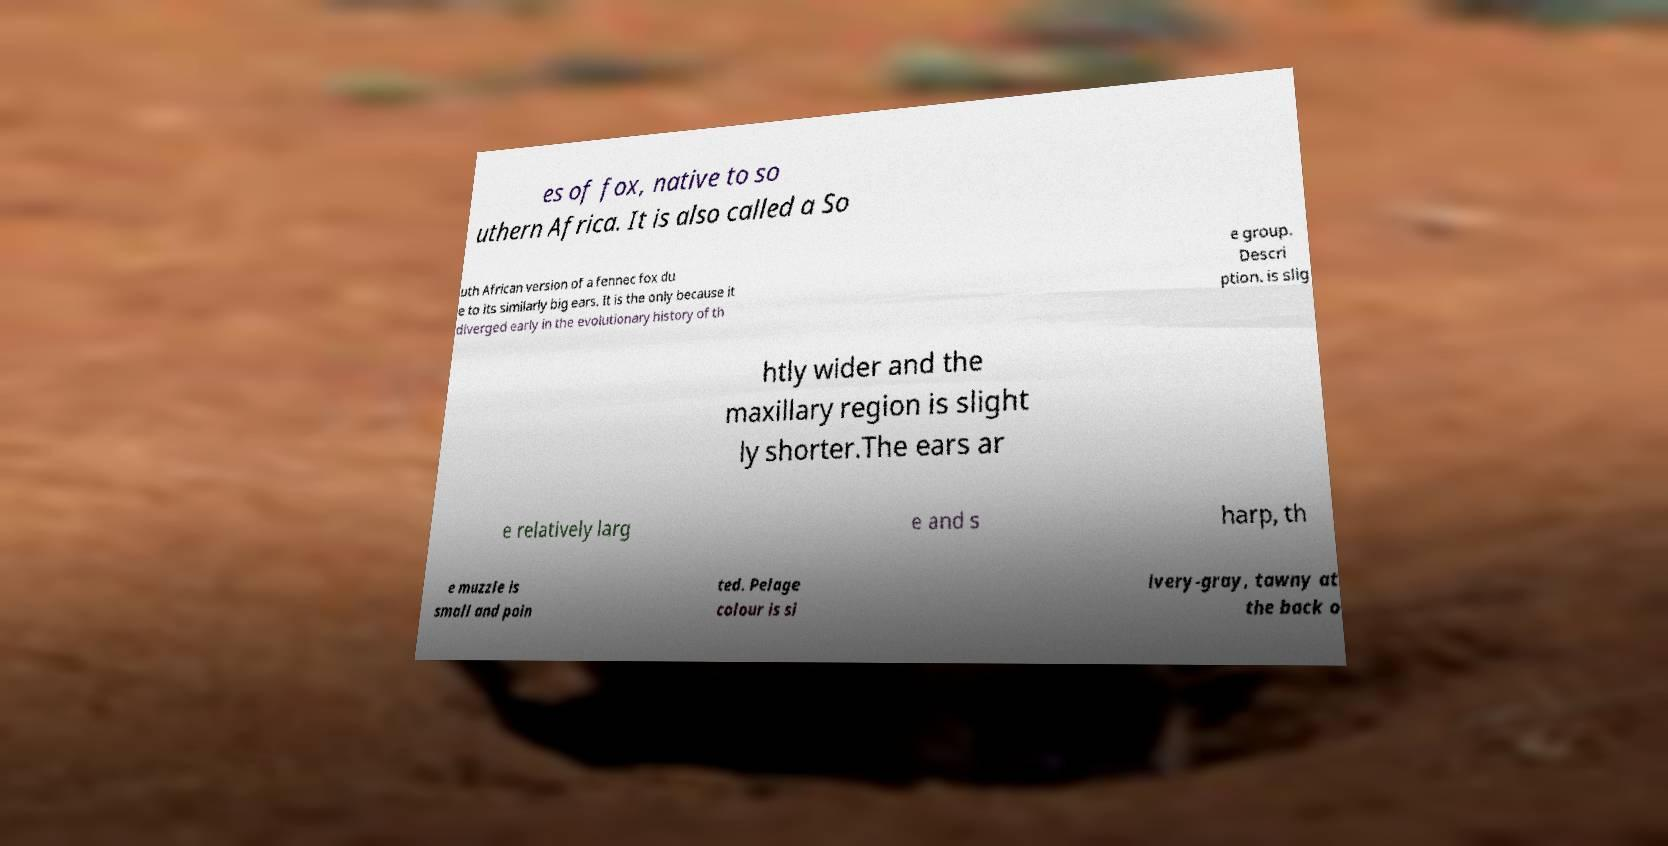I need the written content from this picture converted into text. Can you do that? es of fox, native to so uthern Africa. It is also called a So uth African version of a fennec fox du e to its similarly big ears. It is the only because it diverged early in the evolutionary history of th e group. Descri ption. is slig htly wider and the maxillary region is slight ly shorter.The ears ar e relatively larg e and s harp, th e muzzle is small and poin ted. Pelage colour is si lvery-gray, tawny at the back o 